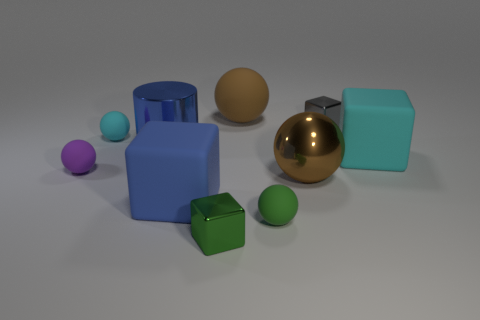Imagine if these objects were part of a toy set, what sort of game could they be used for? These objects could be part of an educational toy set designed to teach children about shapes and colors. A possible game could involve matching similar shapes or creating patterns with the objects based on the colors. Could these objects represent any concept or metaphor, in a more abstract sense? In an abstract sense, these objects might represent diversity and unity. Each object is unique in shape and color, yet they are all arranged together in harmony, which could symbolize the idea of different elements or individuals coming together to form a cohesive whole. 